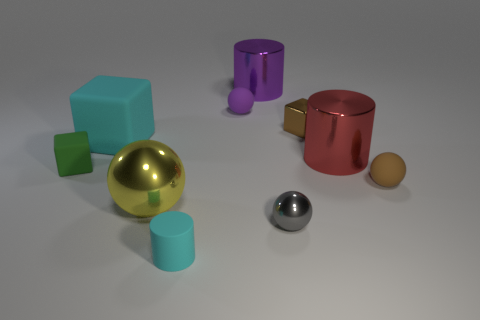There is a small thing in front of the gray sphere; is its shape the same as the small rubber object behind the red cylinder?
Ensure brevity in your answer.  No. There is a green cube; how many tiny balls are in front of it?
Your answer should be compact. 2. Is there a yellow ball that has the same material as the small green object?
Your response must be concise. No. What is the material of the red thing that is the same size as the purple cylinder?
Offer a very short reply. Metal. Are the tiny cyan thing and the green block made of the same material?
Provide a succinct answer. Yes. How many objects are blocks or brown balls?
Make the answer very short. 4. What is the shape of the cyan thing that is in front of the tiny brown rubber sphere?
Provide a succinct answer. Cylinder. The tiny ball that is the same material as the large ball is what color?
Provide a succinct answer. Gray. What material is the small object that is the same shape as the large purple thing?
Provide a succinct answer. Rubber. There is a tiny brown metallic object; what shape is it?
Ensure brevity in your answer.  Cube. 